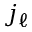Convert formula to latex. <formula><loc_0><loc_0><loc_500><loc_500>j _ { \ell }</formula> 